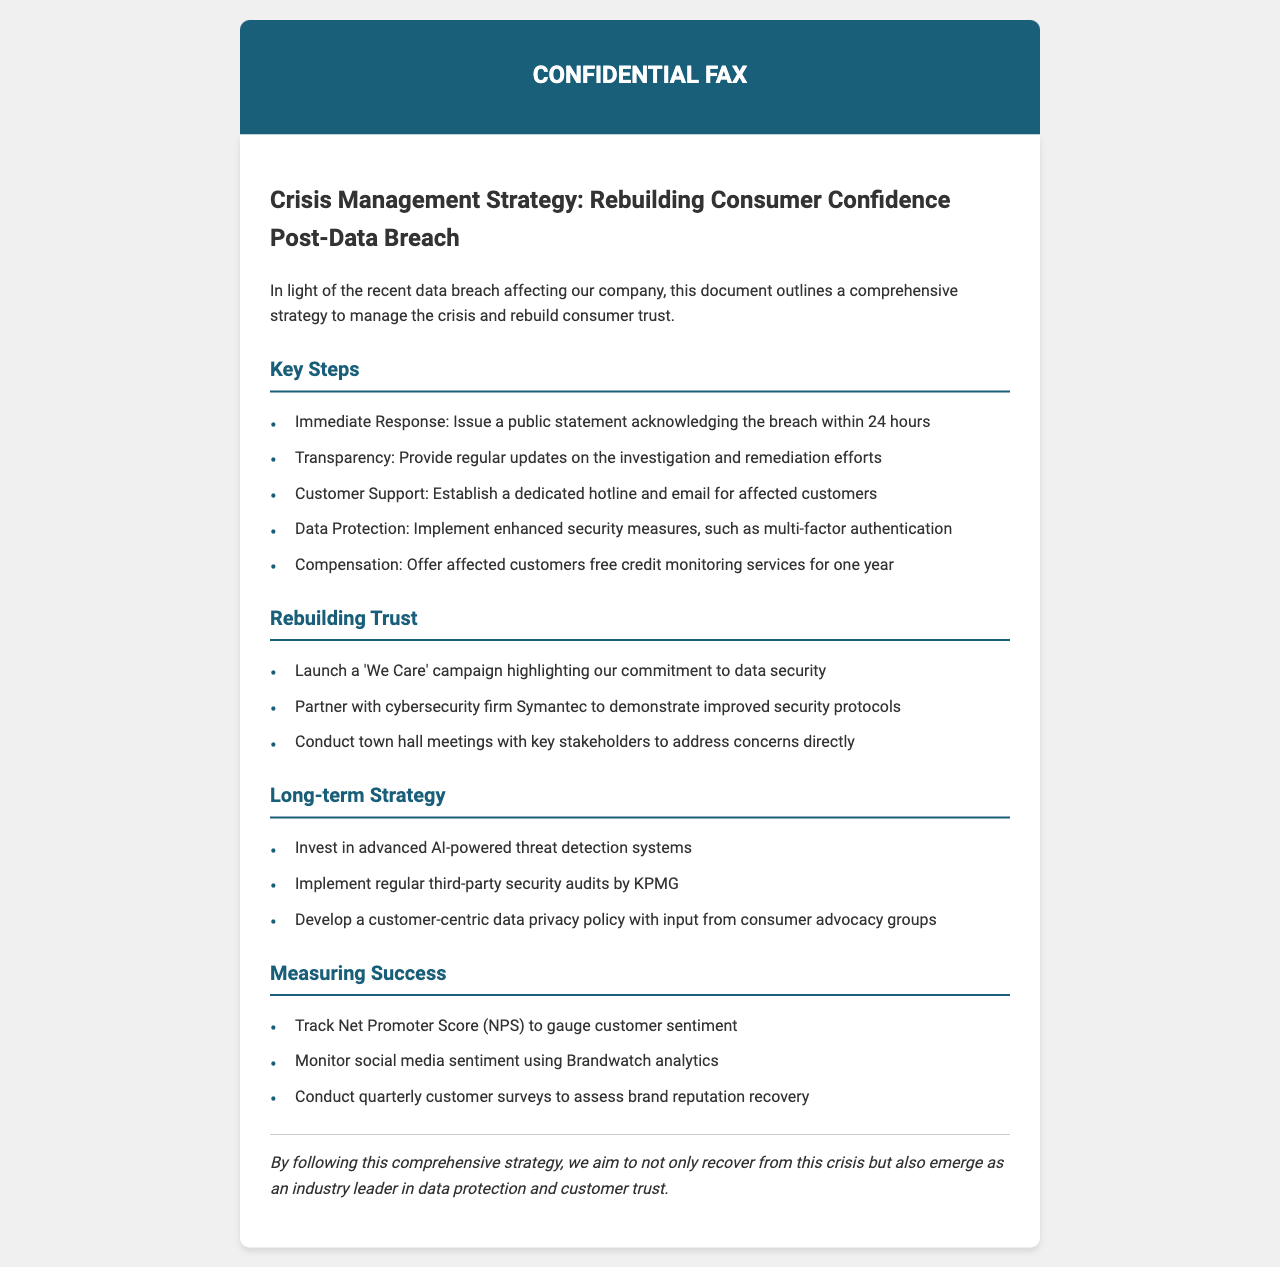What is the title of the fax? The title of the fax is highlighted at the top of the document.
Answer: Crisis Management Strategy: Rebuilding Consumer Confidence Post-Data Breach How many immediate response actions are listed? The number of immediate response actions can be counted from the section titled "Key Steps."
Answer: Five What does the 'We Care' campaign aim to highlight? The goal of the campaign is detailed in the "Rebuilding Trust" section.
Answer: Commitment to data security Which cybersecurity firm has the company partnered with? The partner is specified in the second actionable step under "Rebuilding Trust."
Answer: Symantec What form of compensation is offered to affected customers? The compensation is detailed in the "Key Steps" section related to customer support.
Answer: Free credit monitoring services for one year What method will be used to track customer sentiment? The method is listed in the "Measuring Success" section.
Answer: Net Promoter Score (NPS) How often will customer surveys be conducted? The frequency is indicated in the "Measuring Success" section of the document.
Answer: Quarterly What type of audits will the company implement for long-term strategy? The type of audits is mentioned in the "Long-term Strategy" section.
Answer: Third-party security audits 